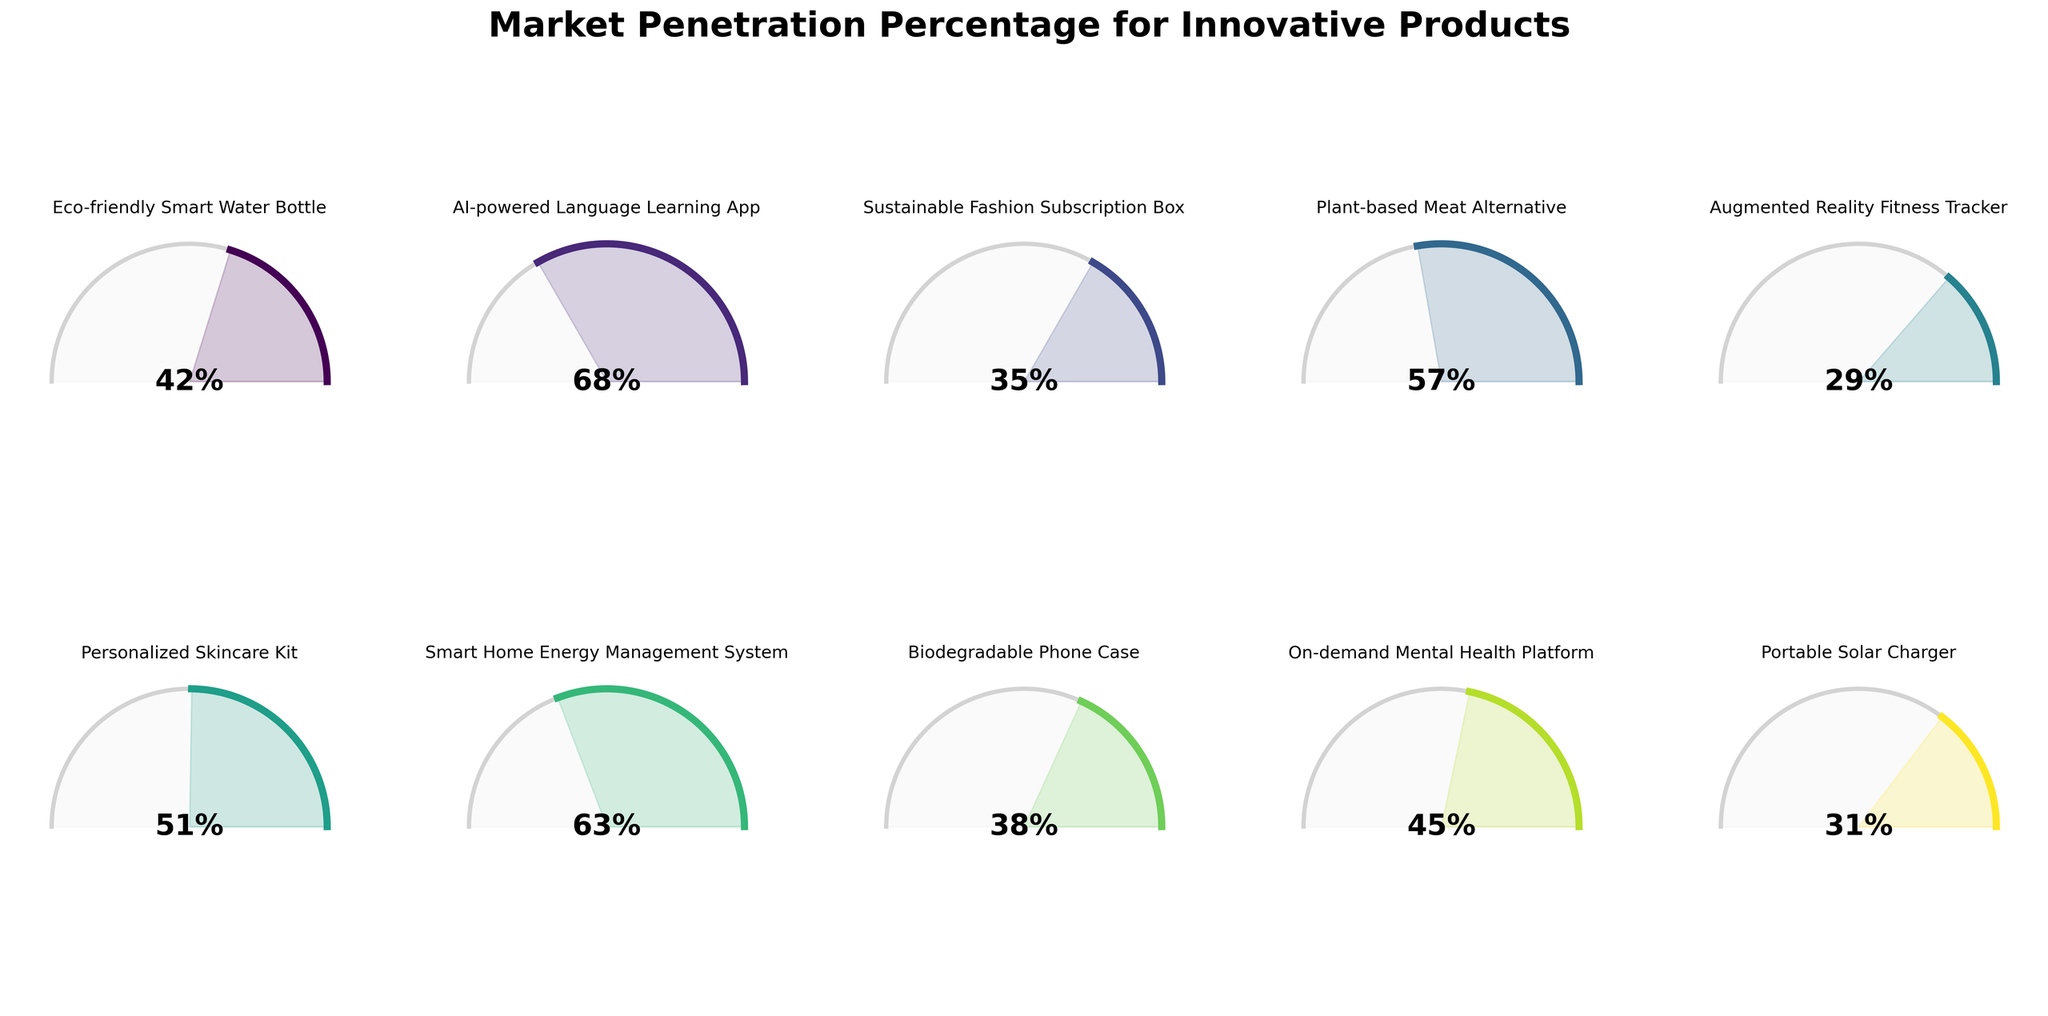Which product has the highest market penetration percentage? The AI-powered Language Learning App shows the highest market penetration percentage on the gauge chart.
Answer: AI-powered Language Learning App What is the market penetration percentage of the Personalized Skincare Kit? By referring to the gauge chart, the market penetration percentage of the Personalized Skincare Kit is displayed as 51%.
Answer: 51% How many products have a market penetration percentage greater than 50%? By examining the gauge chart, the Eco-friendly Smart Water Bottle (42%), AI-powered Language Learning App (68%), Plant-based Meat Alternative (57%), Personalized Skincare Kit (51%), and Smart Home Energy Management System (63%) all have market penetrations over 50%.
Answer: 4 Which product has the lowest market penetration percentage? The gauge chart shows that the Augmented Reality Fitness Tracker has the lowest market penetration percentage.
Answer: Augmented Reality Fitness Tracker What is the average market penetration percentage of all the products? Adding up all the market penetration percentages (42, 68, 35, 57, 29, 51, 63, 38, 45, 31) gives a total of 459. Dividing this by the number of products (10) gives the average as 459/10 = 45.9.
Answer: 45.9 What is the market penetration percentage difference between the Eco-friendly Smart Water Bottle and the Biodegradable Phone Case? The Eco-friendly Smart Water Bottle has a market penetration of 42%, and the Biodegradable Phone Case has 38%. The difference is 42 - 38 = 4%.
Answer: 4% Compare the market penetration percentages of the Plant-based Meat Alternative and the Portable Solar Charger. Which one has a higher percentage? From the gauge chart, the Plant-based Meat Alternative has a 57% market penetration while the Portable Solar Charger has 31%. Thus, the Plant-based Meat Alternative has a higher percentage.
Answer: Plant-based Meat Alternative What is the median market penetration percentage? Ordering the market penetration percentages (29, 31, 35, 38, 42, 45, 51, 57, 63, 68), the median is the average of the middle two numbers 42 and 45, which is (42 + 45) / 2 = 43.5%.
Answer: 43.5 What proportion of the products have a market penetration percentage over 40%? Counting the products with market penetration over 40%, there are six: Eco-friendly Smart Water Bottle, AI-powered Language Learning App, Plant-based Meat Alternative, Personalized Skincare Kit, Smart Home Energy Management System, and On-demand Mental Health Platform. Thus, 6 out of 10 is 6/10 = 0.6 or 60%.
Answer: 60% Which product is closest to the average market penetration percentage? The average market penetration percentage is 45.9%. The Eco-friendly Smart Water Bottle (42%), On-demand Mental Health Platform (45%), and Personalized Skincare Kit (51%) are close, but the On-demand Mental Health Platform at 45% is closest to 45.9%.
Answer: On-demand Mental Health Platform 